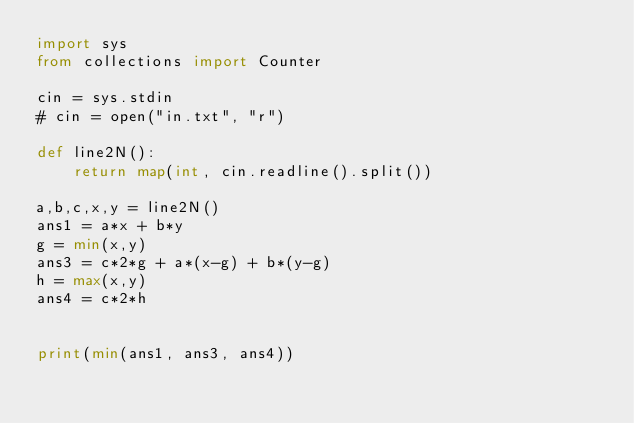<code> <loc_0><loc_0><loc_500><loc_500><_Python_>import sys
from collections import Counter

cin = sys.stdin
# cin = open("in.txt", "r")

def line2N():
    return map(int, cin.readline().split())

a,b,c,x,y = line2N()
ans1 = a*x + b*y
g = min(x,y)
ans3 = c*2*g + a*(x-g) + b*(y-g)
h = max(x,y)
ans4 = c*2*h


print(min(ans1, ans3, ans4))
</code> 